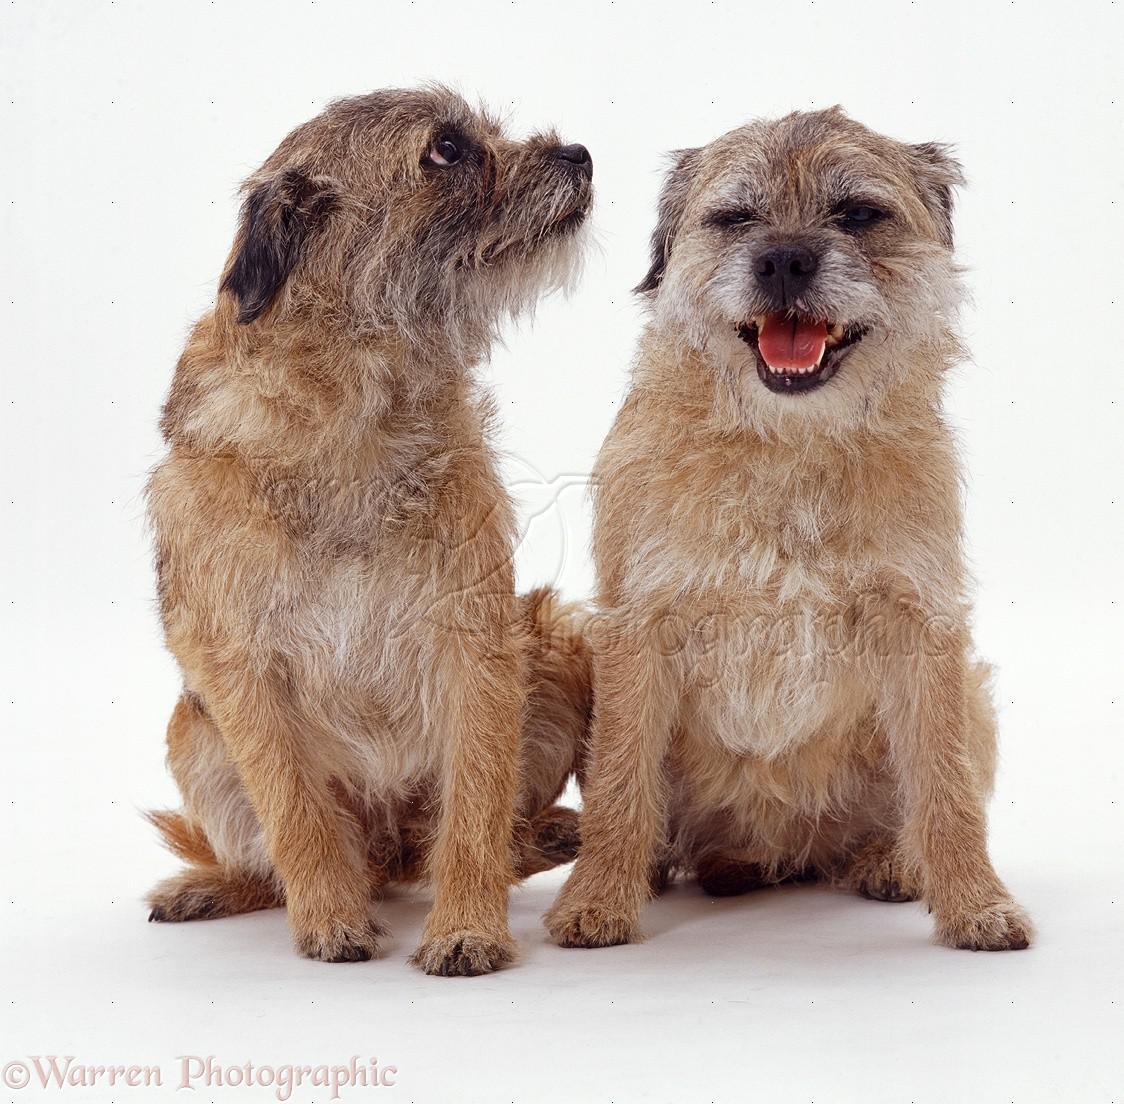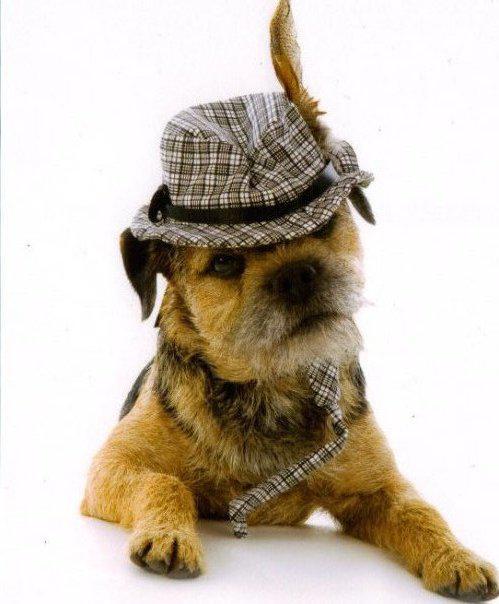The first image is the image on the left, the second image is the image on the right. For the images displayed, is the sentence "the dog has a hat with a brim in the right side pic" factually correct? Answer yes or no. Yes. The first image is the image on the left, the second image is the image on the right. For the images shown, is this caption "The dog in the image on the right is wearing a hat with a black band around the crown." true? Answer yes or no. Yes. 